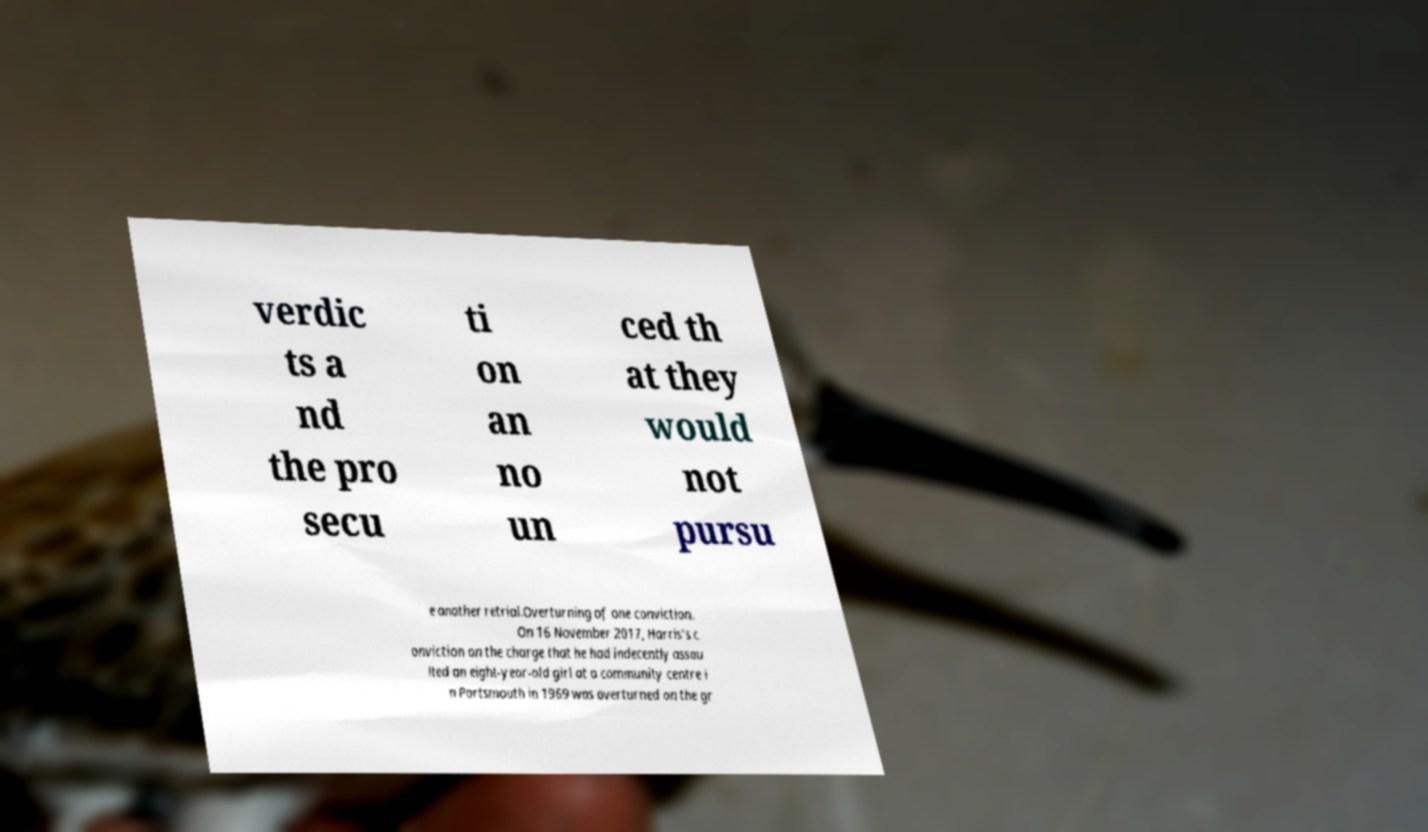Can you read and provide the text displayed in the image?This photo seems to have some interesting text. Can you extract and type it out for me? verdic ts a nd the pro secu ti on an no un ced th at they would not pursu e another retrial.Overturning of one conviction. On 16 November 2017, Harris's c onviction on the charge that he had indecently assau lted an eight-year-old girl at a community centre i n Portsmouth in 1969 was overturned on the gr 